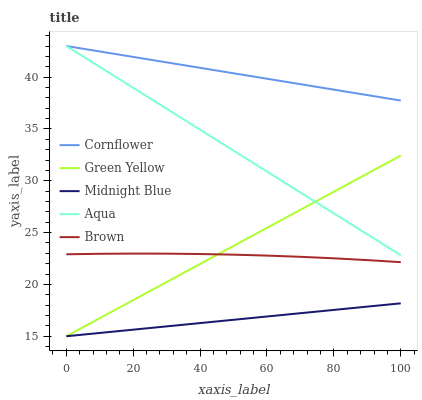Does Midnight Blue have the minimum area under the curve?
Answer yes or no. Yes. Does Cornflower have the maximum area under the curve?
Answer yes or no. Yes. Does Green Yellow have the minimum area under the curve?
Answer yes or no. No. Does Green Yellow have the maximum area under the curve?
Answer yes or no. No. Is Cornflower the smoothest?
Answer yes or no. Yes. Is Brown the roughest?
Answer yes or no. Yes. Is Green Yellow the smoothest?
Answer yes or no. No. Is Green Yellow the roughest?
Answer yes or no. No. Does Aqua have the lowest value?
Answer yes or no. No. Does Aqua have the highest value?
Answer yes or no. Yes. Does Green Yellow have the highest value?
Answer yes or no. No. Is Midnight Blue less than Brown?
Answer yes or no. Yes. Is Aqua greater than Brown?
Answer yes or no. Yes. Does Green Yellow intersect Brown?
Answer yes or no. Yes. Is Green Yellow less than Brown?
Answer yes or no. No. Is Green Yellow greater than Brown?
Answer yes or no. No. Does Midnight Blue intersect Brown?
Answer yes or no. No. 